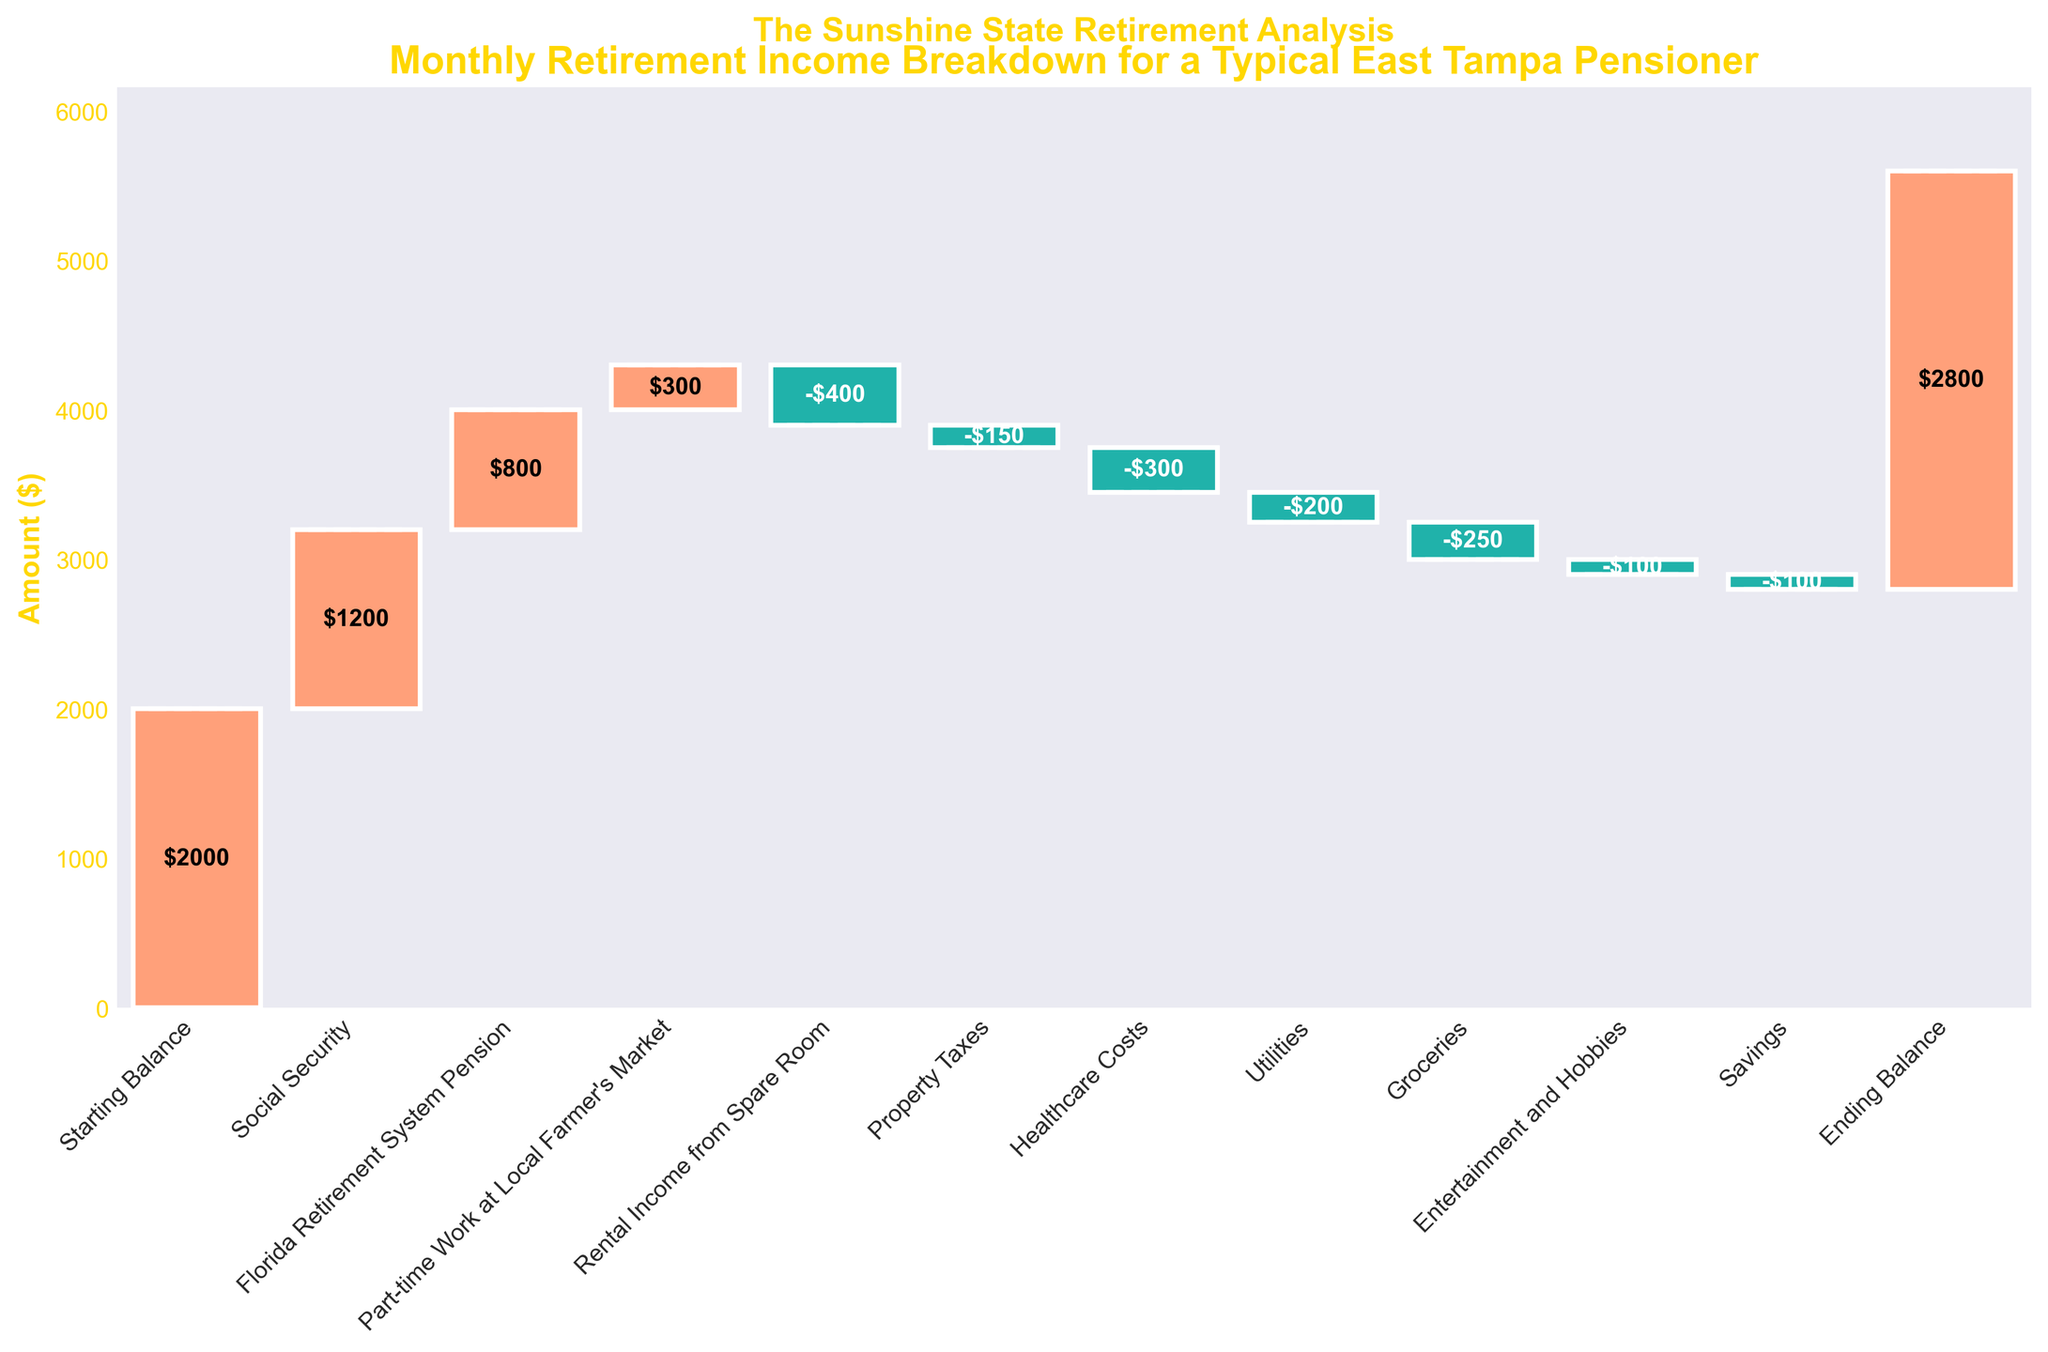What is the title of the chart? The title is clearly displayed at the top of the chart and provides an overview of what the chart represents.
Answer: Monthly Retirement Income Breakdown for a Typical East Tampa Pensioner What's the total starting balance? The first bar in the chart, labeled "Starting Balance," indicates the initial total amount before other incomes and expenses are added or subtracted.
Answer: $2000 How much is contributed by Social Security? The bar labeled "Social Security" shows the amount added by Social Security benefits.
Answer: $1200 Which category has the largest negative value? Looking at the bars colored differently (dark green for negative values), we see the "Rental Income from Spare Room" has the largest negative value.
Answer: -$400 Which category has the highest positive value? Checking the bars, "Social Security" has the highest positive contribution.
Answer: $1200 What is the ending balance? The final bar labeled "Ending Balance" shows the total remaining amount after all additions and subtractions.
Answer: $2800 Calculate the net gain or loss from non-starting and non-ending categories? Sum the positive values (1200 + 800 + 300) and subtract the negative values (-400 -150 -300 -200 -250 -100 -100). Net gain/loss = (1200 + 800 + 300) - (400 + 150 + 300 + 200 + 250 + 100 + 100) = 2300 - 1500 = 800.
Answer: $800 What categories contribute positively? Identify all bars with positive values by their category names: "Social Security," "Florida Retirement System Pension," and "Part-time Work at Local Farmer's Market."
Answer: Social Security, Florida Retirement System Pension, Part-time Work at Local Farmer's Market Compare the contributions of "Healthcare Costs" and "Property Taxes." Which is higher? The "Healthcare Costs" is -$300 and "Property Taxes" is -$150. Since -300 is less than -150, Property Taxes is higher.
Answer: Property Taxes What is the color theme for positive and negative values? Positive values are shown in a light salmon color (typically a warm color representing gain), whereas negative values are shown in a light sea-green color (representing loss).
Answer: Light salmon for positive, light sea-green for negative 